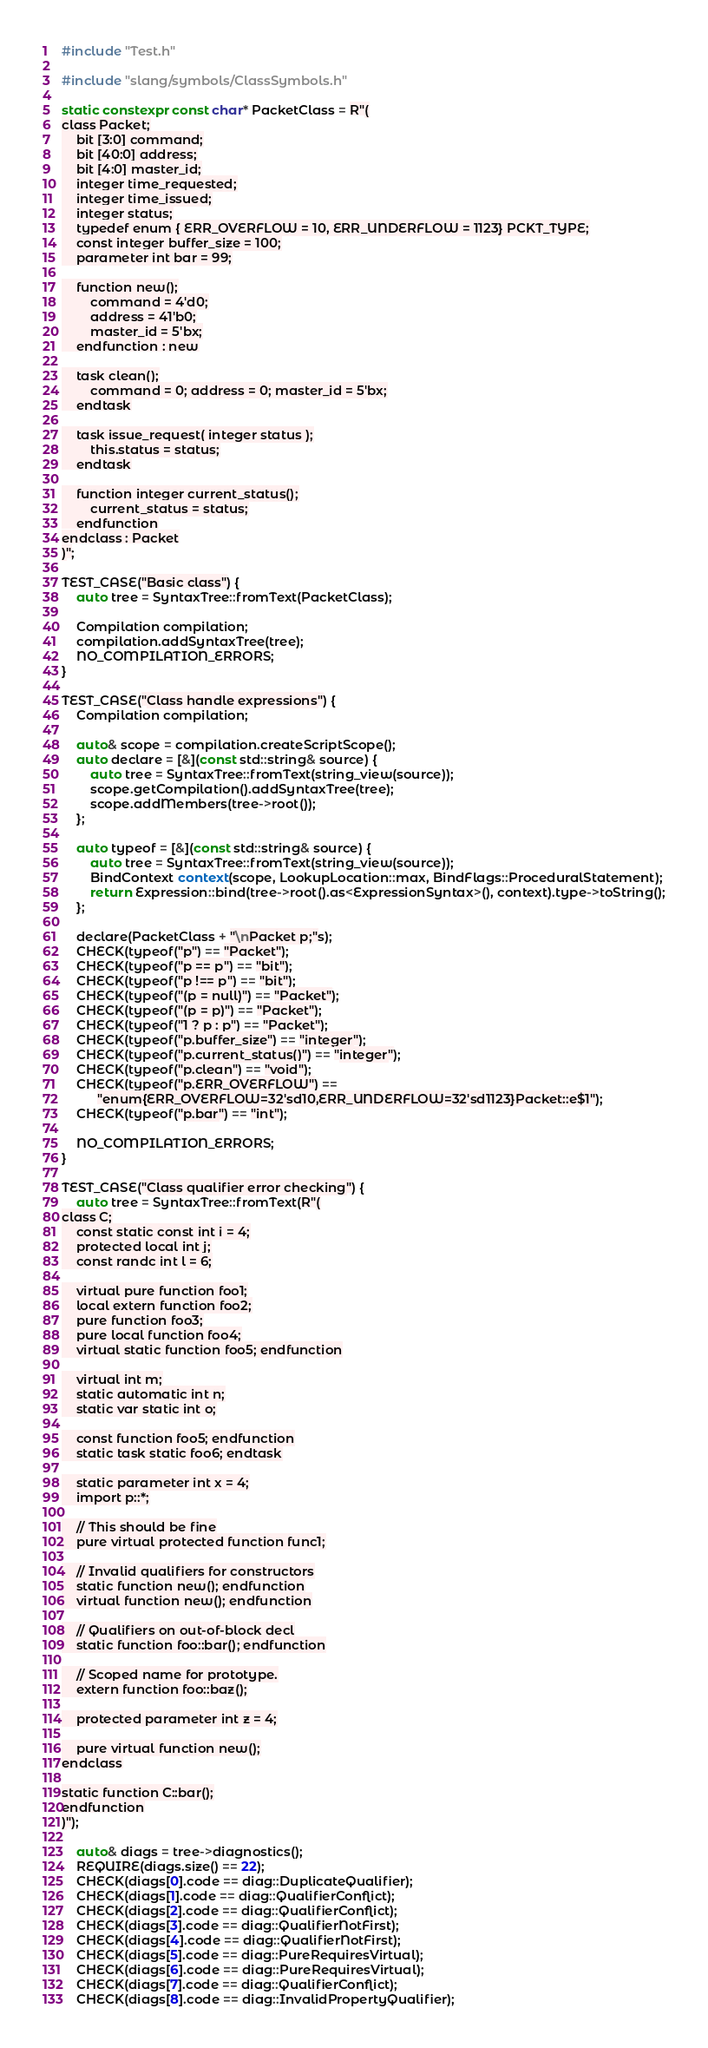<code> <loc_0><loc_0><loc_500><loc_500><_C++_>#include "Test.h"

#include "slang/symbols/ClassSymbols.h"

static constexpr const char* PacketClass = R"(
class Packet;
    bit [3:0] command;
    bit [40:0] address;
    bit [4:0] master_id;
    integer time_requested;
    integer time_issued;
    integer status;
    typedef enum { ERR_OVERFLOW = 10, ERR_UNDERFLOW = 1123} PCKT_TYPE;
    const integer buffer_size = 100;
    parameter int bar = 99;

    function new();
        command = 4'd0;
        address = 41'b0;
        master_id = 5'bx;
    endfunction : new

    task clean();
        command = 0; address = 0; master_id = 5'bx;
    endtask

    task issue_request( integer status );
        this.status = status;
    endtask

    function integer current_status();
        current_status = status;
    endfunction
endclass : Packet
)";

TEST_CASE("Basic class") {
    auto tree = SyntaxTree::fromText(PacketClass);

    Compilation compilation;
    compilation.addSyntaxTree(tree);
    NO_COMPILATION_ERRORS;
}

TEST_CASE("Class handle expressions") {
    Compilation compilation;

    auto& scope = compilation.createScriptScope();
    auto declare = [&](const std::string& source) {
        auto tree = SyntaxTree::fromText(string_view(source));
        scope.getCompilation().addSyntaxTree(tree);
        scope.addMembers(tree->root());
    };

    auto typeof = [&](const std::string& source) {
        auto tree = SyntaxTree::fromText(string_view(source));
        BindContext context(scope, LookupLocation::max, BindFlags::ProceduralStatement);
        return Expression::bind(tree->root().as<ExpressionSyntax>(), context).type->toString();
    };

    declare(PacketClass + "\nPacket p;"s);
    CHECK(typeof("p") == "Packet");
    CHECK(typeof("p == p") == "bit");
    CHECK(typeof("p !== p") == "bit");
    CHECK(typeof("(p = null)") == "Packet");
    CHECK(typeof("(p = p)") == "Packet");
    CHECK(typeof("1 ? p : p") == "Packet");
    CHECK(typeof("p.buffer_size") == "integer");
    CHECK(typeof("p.current_status()") == "integer");
    CHECK(typeof("p.clean") == "void");
    CHECK(typeof("p.ERR_OVERFLOW") ==
          "enum{ERR_OVERFLOW=32'sd10,ERR_UNDERFLOW=32'sd1123}Packet::e$1");
    CHECK(typeof("p.bar") == "int");

    NO_COMPILATION_ERRORS;
}

TEST_CASE("Class qualifier error checking") {
    auto tree = SyntaxTree::fromText(R"(
class C;
    const static const int i = 4;
    protected local int j;
    const randc int l = 6;

    virtual pure function foo1;
    local extern function foo2;
    pure function foo3;
    pure local function foo4;
    virtual static function foo5; endfunction

    virtual int m;
    static automatic int n;
    static var static int o;

    const function foo5; endfunction
    static task static foo6; endtask

    static parameter int x = 4;
    import p::*;

    // This should be fine
    pure virtual protected function func1;

    // Invalid qualifiers for constructors
    static function new(); endfunction
    virtual function new(); endfunction

    // Qualifiers on out-of-block decl
    static function foo::bar(); endfunction

    // Scoped name for prototype.
    extern function foo::baz();

    protected parameter int z = 4;

    pure virtual function new();
endclass

static function C::bar();
endfunction
)");

    auto& diags = tree->diagnostics();
    REQUIRE(diags.size() == 22);
    CHECK(diags[0].code == diag::DuplicateQualifier);
    CHECK(diags[1].code == diag::QualifierConflict);
    CHECK(diags[2].code == diag::QualifierConflict);
    CHECK(diags[3].code == diag::QualifierNotFirst);
    CHECK(diags[4].code == diag::QualifierNotFirst);
    CHECK(diags[5].code == diag::PureRequiresVirtual);
    CHECK(diags[6].code == diag::PureRequiresVirtual);
    CHECK(diags[7].code == diag::QualifierConflict);
    CHECK(diags[8].code == diag::InvalidPropertyQualifier);</code> 